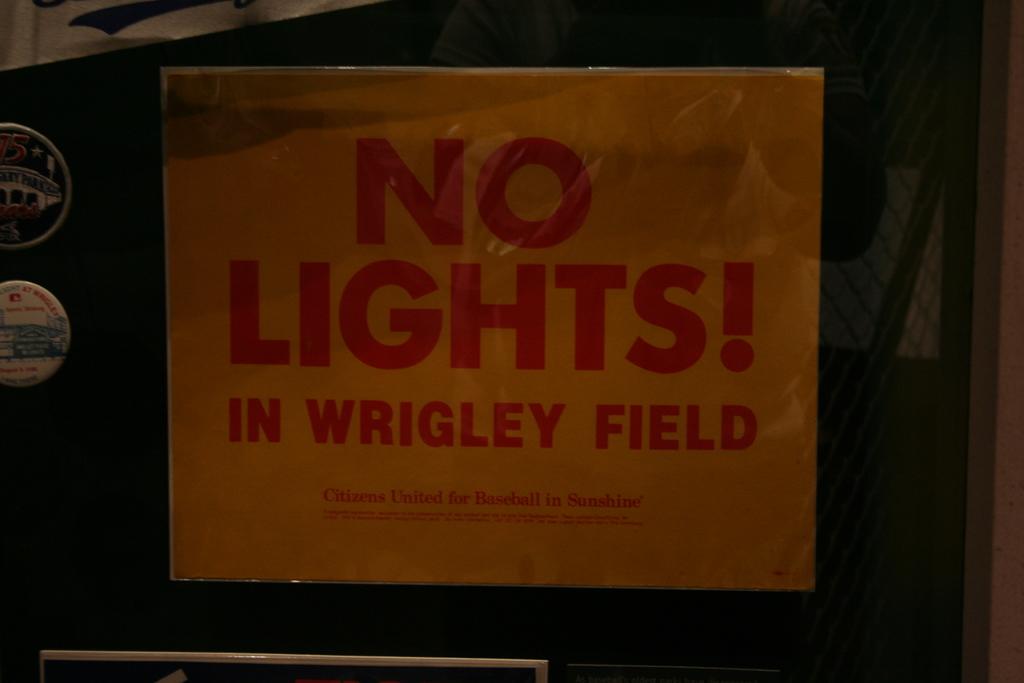What field does this mention?
Offer a very short reply. Wrigley. What is written in small letters under the main red text?
Your answer should be very brief. Citizens united for baseball in sunshine. 